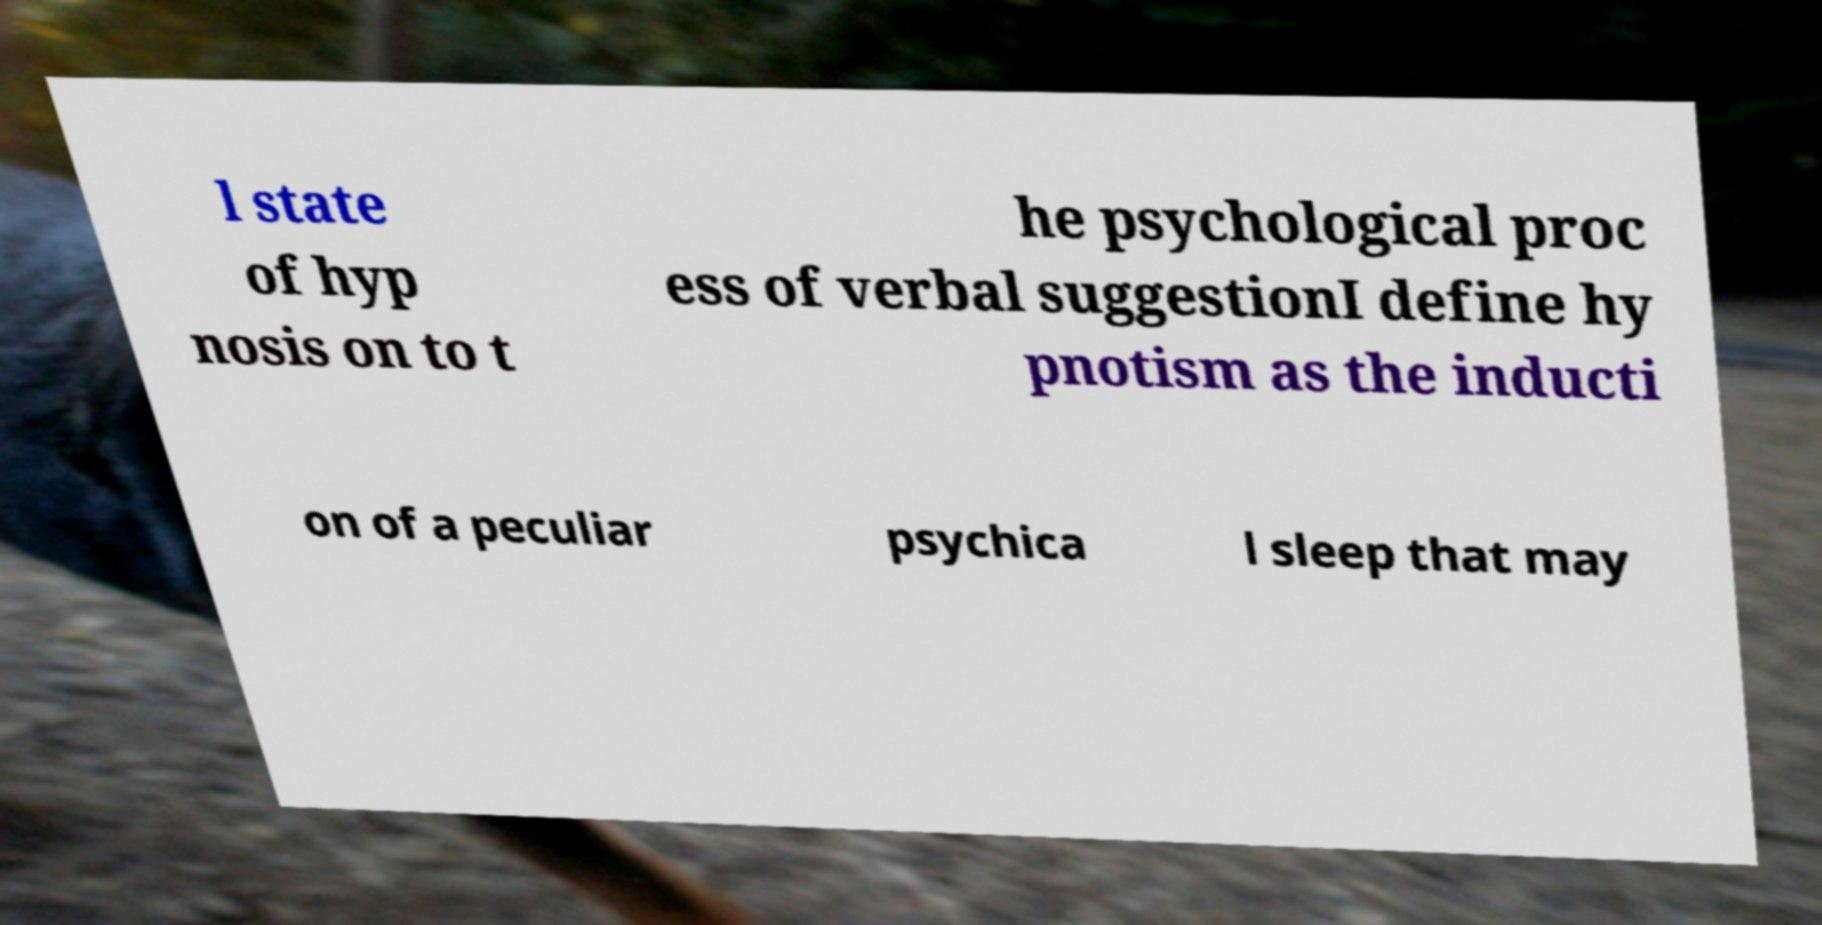For documentation purposes, I need the text within this image transcribed. Could you provide that? l state of hyp nosis on to t he psychological proc ess of verbal suggestionI define hy pnotism as the inducti on of a peculiar psychica l sleep that may 